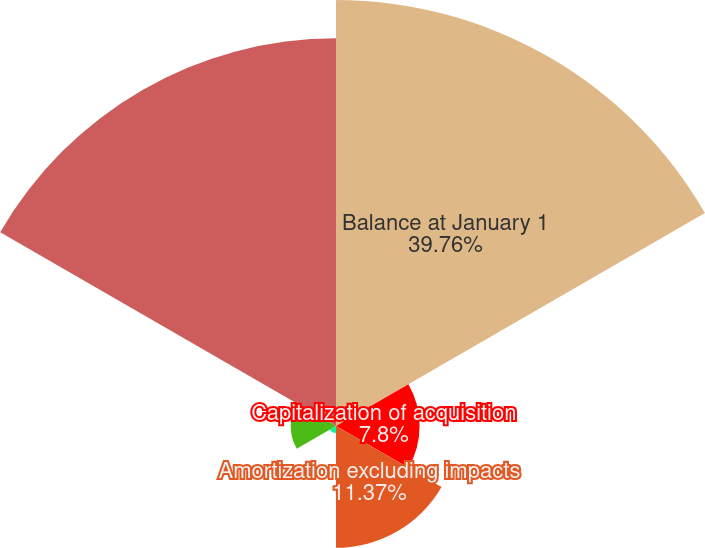<chart> <loc_0><loc_0><loc_500><loc_500><pie_chart><fcel>Balance at January 1<fcel>Capitalization of acquisition<fcel>Amortization excluding impacts<fcel>Amortization impact of<fcel>Impact of change in net<fcel>Balance at December 31<nl><fcel>39.75%<fcel>7.8%<fcel>11.37%<fcel>0.66%<fcel>4.23%<fcel>36.18%<nl></chart> 